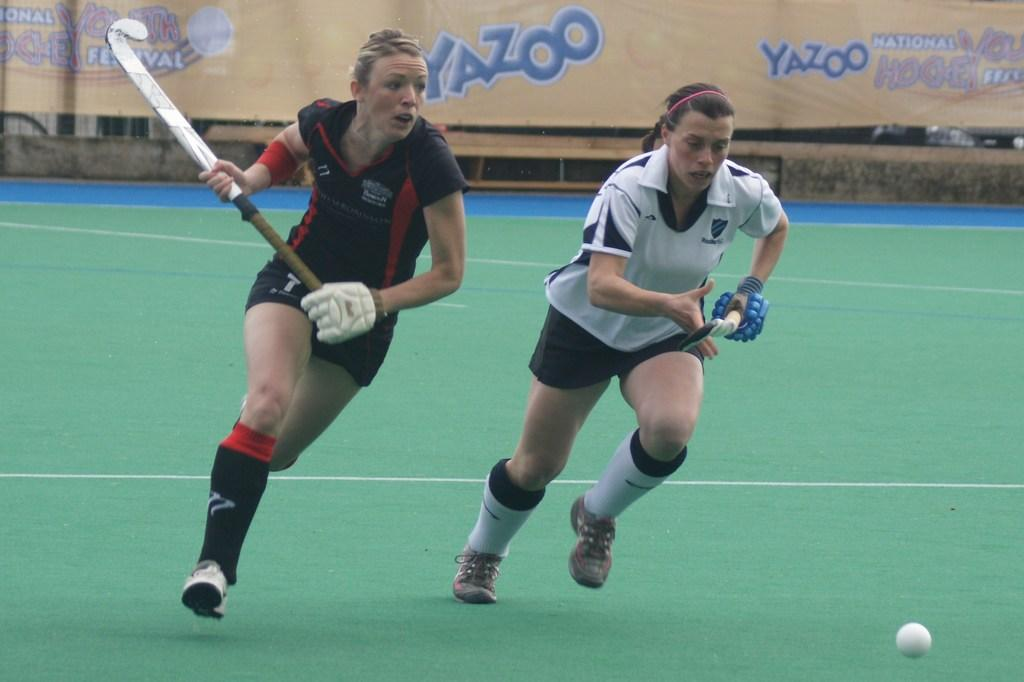What sport are the persons in the image playing? The persons in the image are playing hockey. What can be seen in the background of the image? There is a board with text in the background of the image. What object is being used in the game? There is a white ball in the image. What type of range can be seen in the image? There is no range present in the image; it features persons playing hockey with a white ball. 